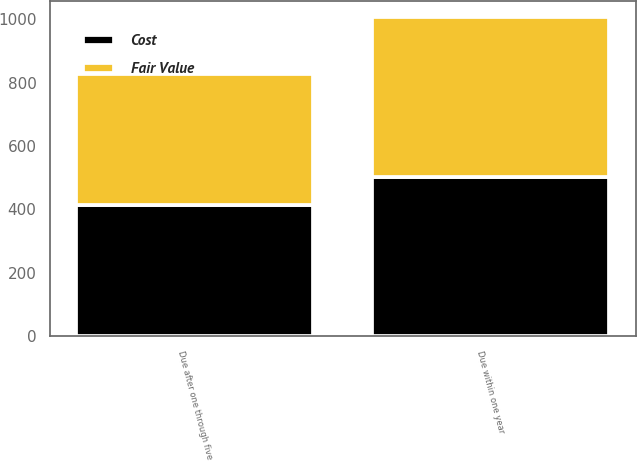Convert chart. <chart><loc_0><loc_0><loc_500><loc_500><stacked_bar_chart><ecel><fcel>Due within one year<fcel>Due after one through five<nl><fcel>Cost<fcel>503.7<fcel>414.3<nl><fcel>Fair Value<fcel>503.7<fcel>414.1<nl></chart> 